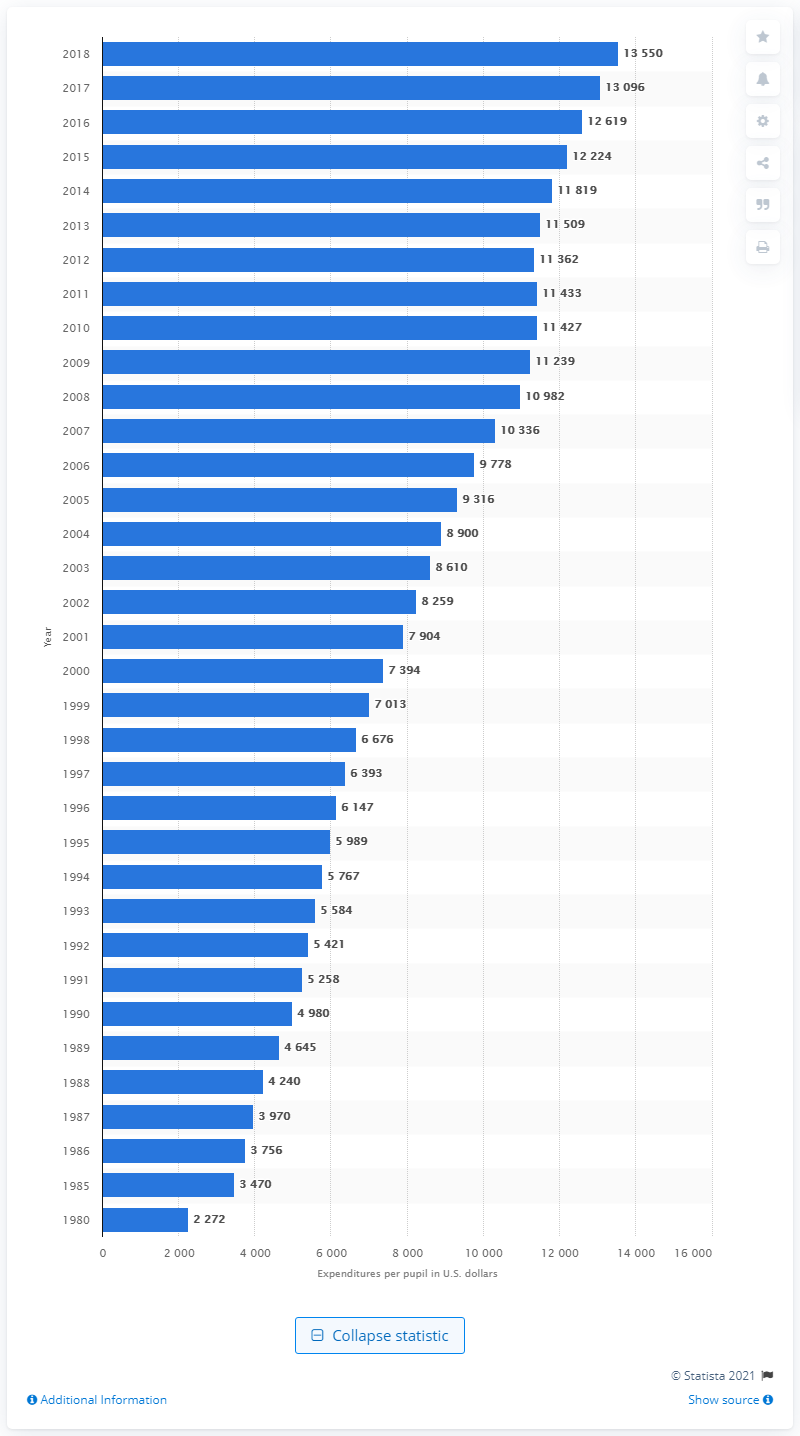Outline some significant characteristics in this image. In the year 1980, a total of 2,272 U.S. dollars were spent per pupil in public elementary and secondary schools in the United States. 